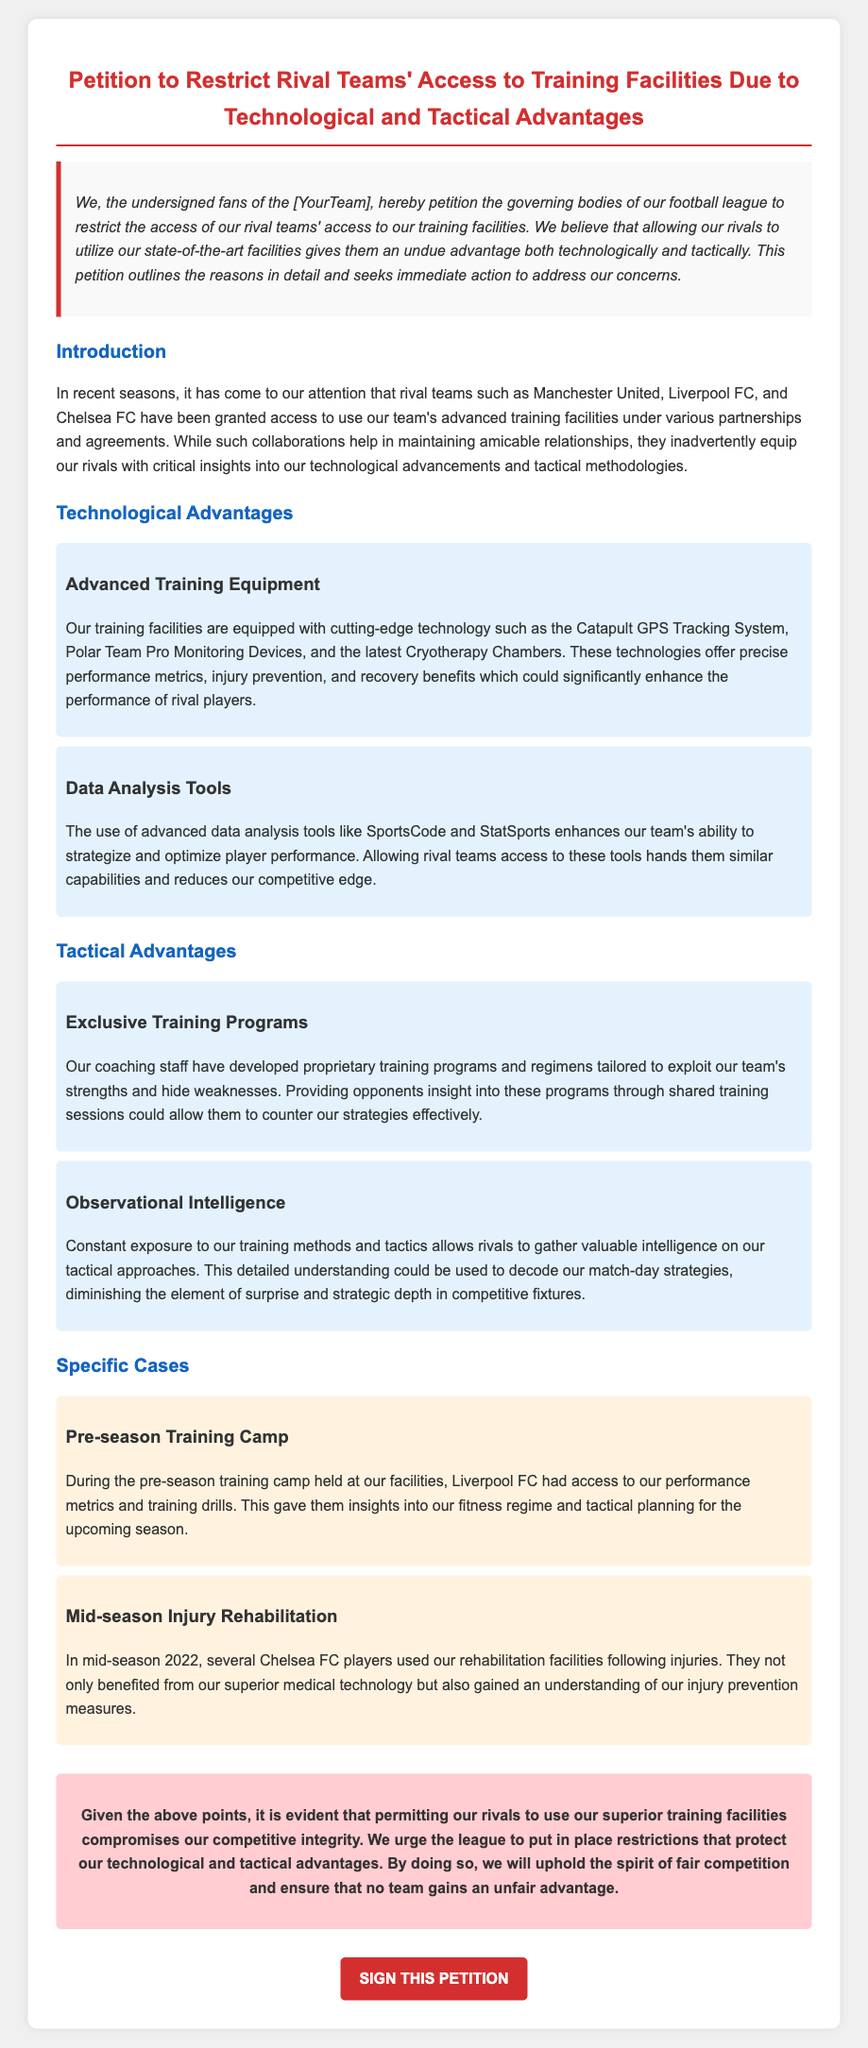What is the title of the petition? The title summarizes the aim and focus of the document regarding restrictions on rival teams' access to training facilities.
Answer: Petition to Restrict Rival Teams' Access to Training Facilities Due to Technological and Tactical Advantages Who are the rival teams mentioned? The document lists specific rival teams that have been given access to the facilities, illustrating the issue at hand.
Answer: Manchester United, Liverpool FC, Chelsea FC What technology is used for performance metrics? The petition features specific technologies aimed at improving team performance, highlighting the advantages of the training facilities.
Answer: Catapult GPS Tracking System What event did Liverpool FC access the training facilities? The document gives an example of when a rival team utilized the training facilities and what they gained from it.
Answer: Pre-season Training Camp What type of advantage is discussed regarding training programs? The petition outlines how the unique nature of training regimens can provide insights to competitors, displaying tactical concerns.
Answer: Exclusive Training Programs How many specific cases are described in the petition? The number of examples provided indicates the level of concern justifying the petition’s claims.
Answer: Two What is the color of the title in the document? The specific color used enhances the visual appeal and highlights the importance of the title.
Answer: Red What action does the conclusion urge the league to take? The conclusion encapsulates the petition’s intent, summarizing the desired action from the governing bodies.
Answer: Put in place restrictions 